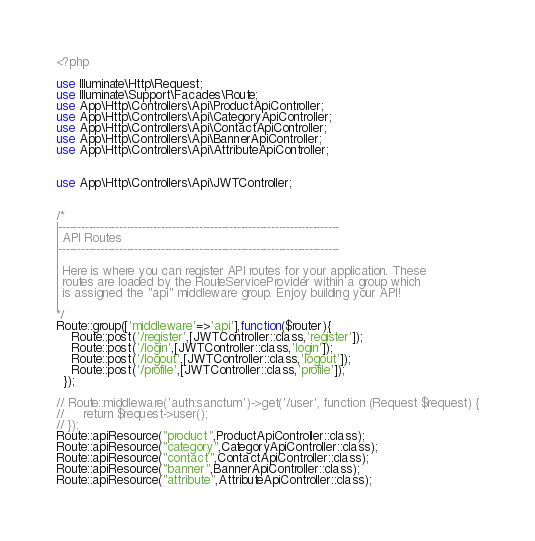<code> <loc_0><loc_0><loc_500><loc_500><_PHP_><?php

use Illuminate\Http\Request;
use Illuminate\Support\Facades\Route;
use App\Http\Controllers\Api\ProductApiController;
use App\Http\Controllers\Api\CategoryApiController;
use App\Http\Controllers\Api\ContactApiController;
use App\Http\Controllers\Api\BannerApiController;
use App\Http\Controllers\Api\AttributeApiController;


use App\Http\Controllers\Api\JWTController;


/*
|--------------------------------------------------------------------------
| API Routes
|--------------------------------------------------------------------------
|
| Here is where you can register API routes for your application. These
| routes are loaded by the RouteServiceProvider within a group which
| is assigned the "api" middleware group. Enjoy building your API!
|
*/
Route::group(['middleware'=>'api'],function($router){
    Route::post('/register',[JWTController::class,'register']);
    Route::post('/login',[JWTController::class,'login']);
    Route::post('/logout',[JWTController::class,'logout']);
    Route::post('/profile',[JWTController::class,'profile']);
  }); 

// Route::middleware('auth:sanctum')->get('/user', function (Request $request) {
//     return $request->user();
// });
Route::apiResource("product",ProductApiController::class);
Route::apiResource("category",CategoryApiController::class);
Route::apiResource("contact",ContactApiController::class);
Route::apiResource("banner",BannerApiController::class);
Route::apiResource("attribute",AttributeApiController::class);
</code> 